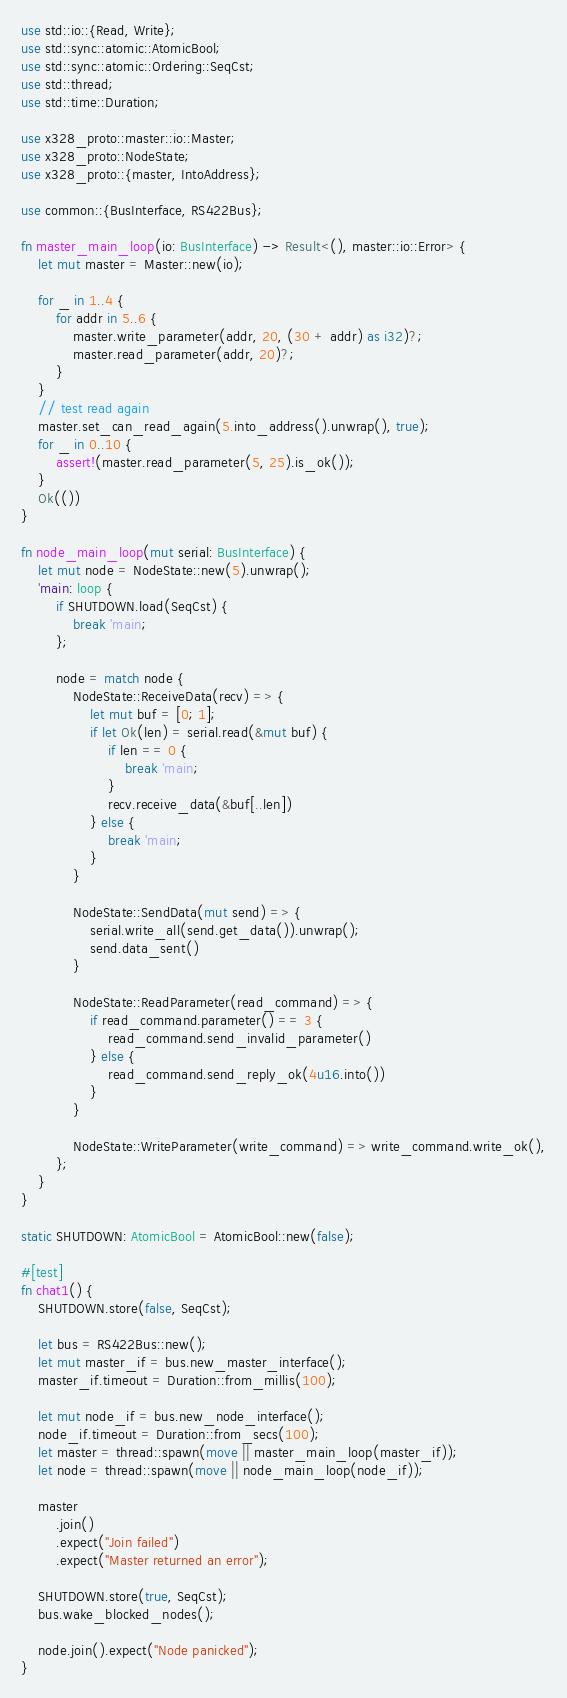<code> <loc_0><loc_0><loc_500><loc_500><_Rust_>use std::io::{Read, Write};
use std::sync::atomic::AtomicBool;
use std::sync::atomic::Ordering::SeqCst;
use std::thread;
use std::time::Duration;

use x328_proto::master::io::Master;
use x328_proto::NodeState;
use x328_proto::{master, IntoAddress};

use common::{BusInterface, RS422Bus};

fn master_main_loop(io: BusInterface) -> Result<(), master::io::Error> {
    let mut master = Master::new(io);

    for _ in 1..4 {
        for addr in 5..6 {
            master.write_parameter(addr, 20, (30 + addr) as i32)?;
            master.read_parameter(addr, 20)?;
        }
    }
    // test read again
    master.set_can_read_again(5.into_address().unwrap(), true);
    for _ in 0..10 {
        assert!(master.read_parameter(5, 25).is_ok());
    }
    Ok(())
}

fn node_main_loop(mut serial: BusInterface) {
    let mut node = NodeState::new(5).unwrap();
    'main: loop {
        if SHUTDOWN.load(SeqCst) {
            break 'main;
        };

        node = match node {
            NodeState::ReceiveData(recv) => {
                let mut buf = [0; 1];
                if let Ok(len) = serial.read(&mut buf) {
                    if len == 0 {
                        break 'main;
                    }
                    recv.receive_data(&buf[..len])
                } else {
                    break 'main;
                }
            }

            NodeState::SendData(mut send) => {
                serial.write_all(send.get_data()).unwrap();
                send.data_sent()
            }

            NodeState::ReadParameter(read_command) => {
                if read_command.parameter() == 3 {
                    read_command.send_invalid_parameter()
                } else {
                    read_command.send_reply_ok(4u16.into())
                }
            }

            NodeState::WriteParameter(write_command) => write_command.write_ok(),
        };
    }
}

static SHUTDOWN: AtomicBool = AtomicBool::new(false);

#[test]
fn chat1() {
    SHUTDOWN.store(false, SeqCst);

    let bus = RS422Bus::new();
    let mut master_if = bus.new_master_interface();
    master_if.timeout = Duration::from_millis(100);

    let mut node_if = bus.new_node_interface();
    node_if.timeout = Duration::from_secs(100);
    let master = thread::spawn(move || master_main_loop(master_if));
    let node = thread::spawn(move || node_main_loop(node_if));

    master
        .join()
        .expect("Join failed")
        .expect("Master returned an error");

    SHUTDOWN.store(true, SeqCst);
    bus.wake_blocked_nodes();

    node.join().expect("Node panicked");
}
</code> 